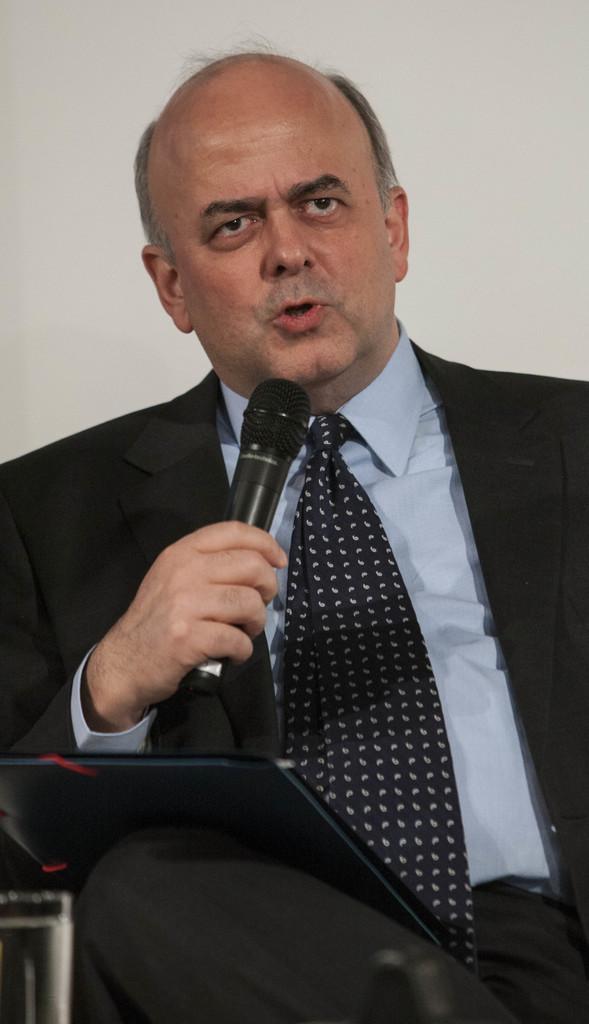Please provide a concise description of this image. In this picture we can see a man wearing a black suit sitting in front and giving a speech in the microphone. Behind there is a white background. 